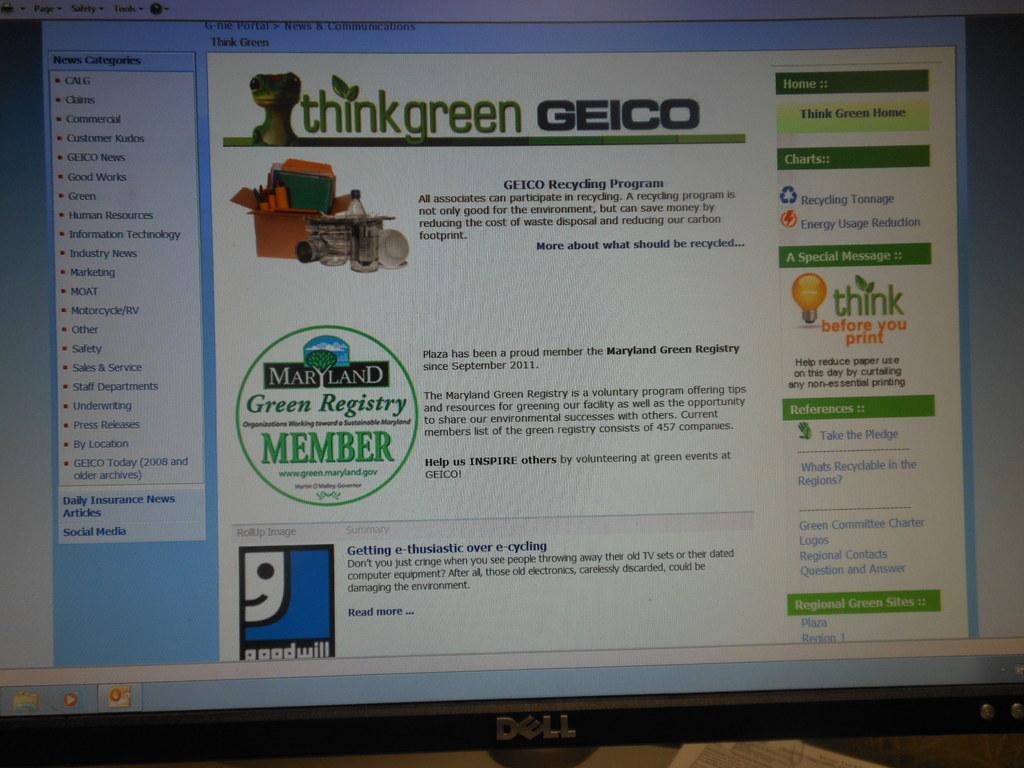What insurance company is on this page?
Offer a very short reply. Geico. What other store is being advertised on the screen?
Your answer should be compact. Goodwill. 